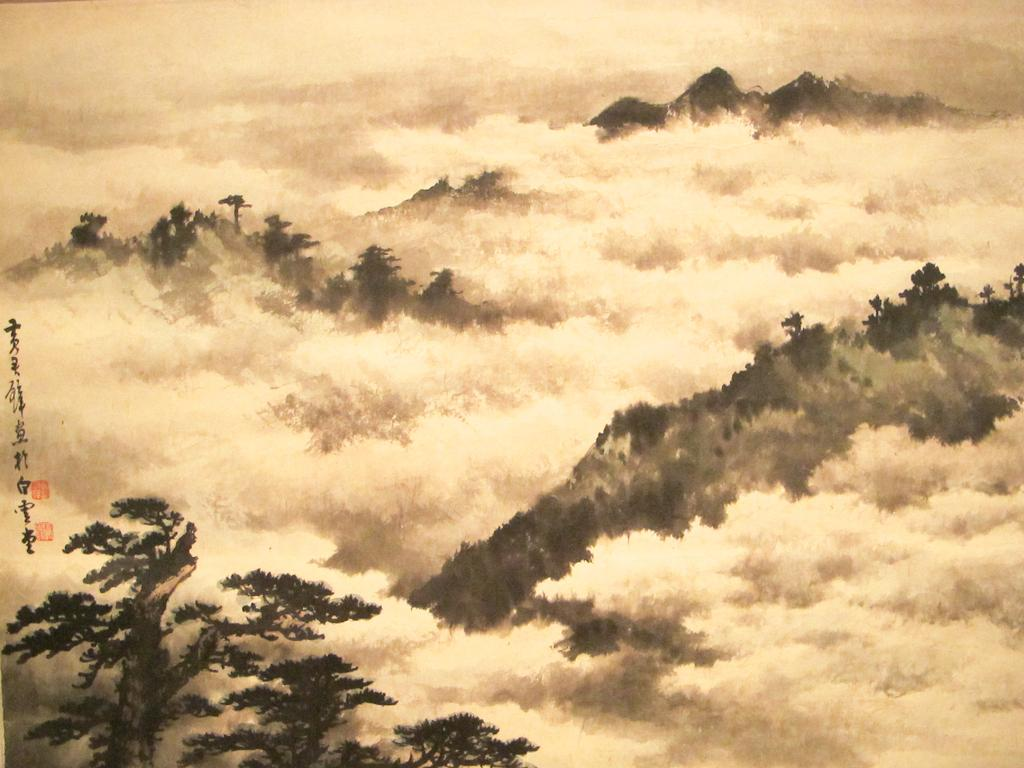What type of natural features can be seen in the image? There are trees and mountains in the image. What is visible in the background of the image? The sky is visible in the image. Are there any trees on the mountains in the image? Yes, there are trees on the mountains in the image. What type of boundary can be seen between the trees and the mountains in the image? There is no boundary visible between the trees and the mountains in the image. What type of acoustics can be heard from the mountains in the image? There is no sound or acoustics mentioned or depicted in the image. Is there a tank visible in the image? There is no tank present in the image. 